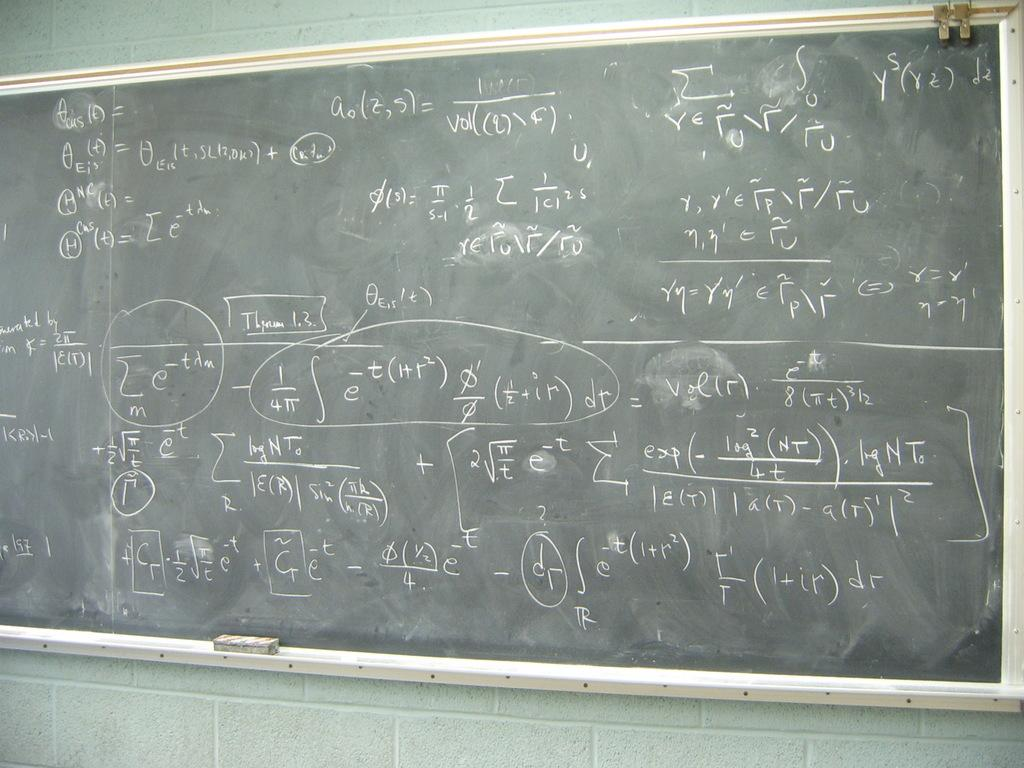Provide a one-sentence caption for the provided image. Chalk board that include equations and fractions on it. 